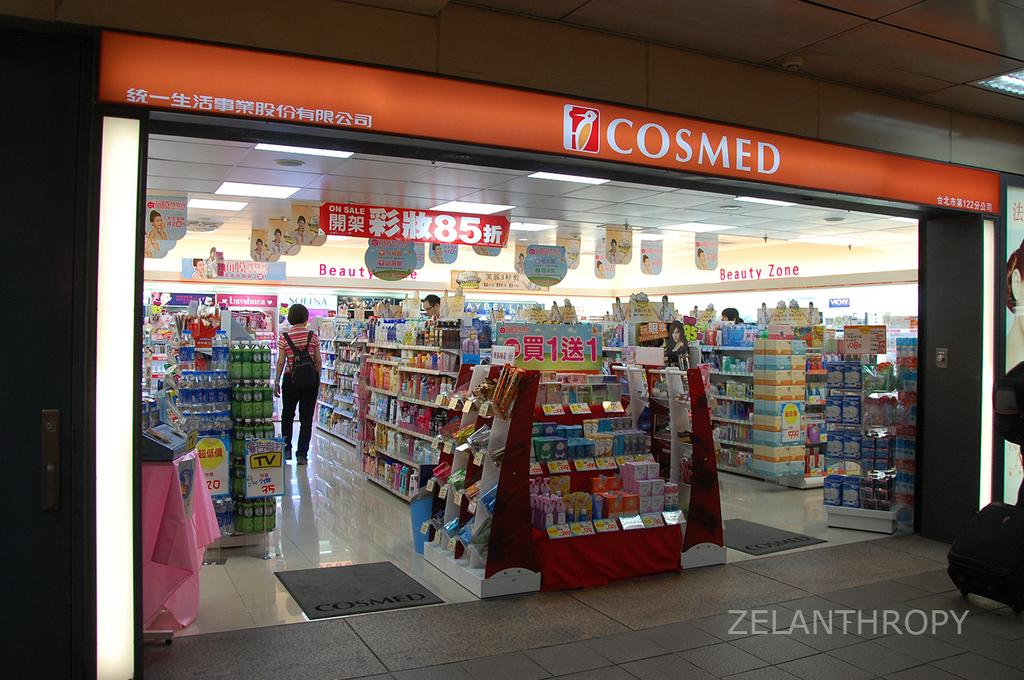<image>
Provide a brief description of the given image. A store front that says cosmed with an orange background. 